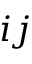<formula> <loc_0><loc_0><loc_500><loc_500>i j</formula> 